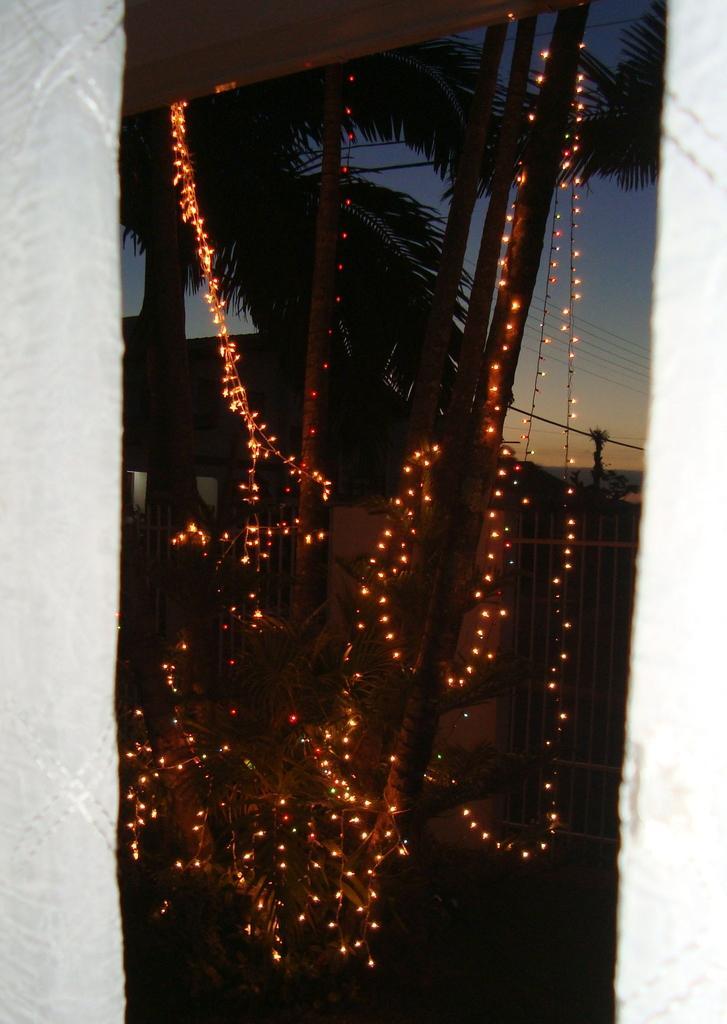Can you describe this image briefly? In this image we can see there are lights tied to the sticks. And at the back it looks like a pole. And there are trees, fence and the sky. 